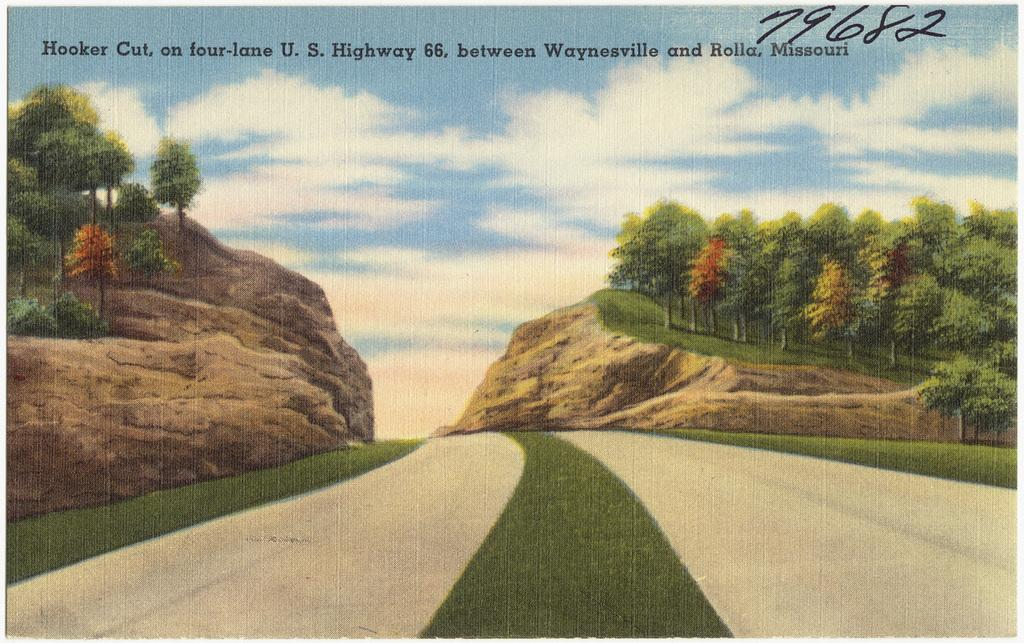What type of visual content is depicted in the image? The image is an animation. What type of natural environment is shown in the image? There are trees in the image, which suggests a natural setting. What type of man-made structure is visible in the image? There is a road in the image. How would you describe the sky in the image? The sky is blue and cloudy. What is present at the top of the picture? There is text on the top of the picture. Can you see a deer running across the road in the image? There is no deer present in the image, and no animals are running across the road. 